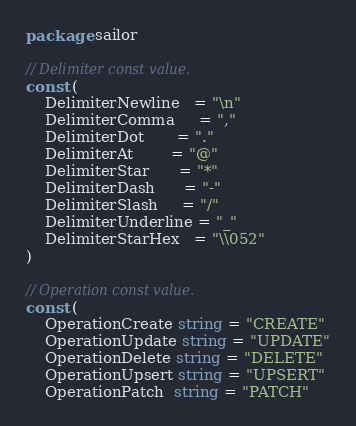<code> <loc_0><loc_0><loc_500><loc_500><_Go_>package sailor

// Delimiter const value.
const (
	DelimiterNewline   = "\n"
	DelimiterComma     = ","
	DelimiterDot       = "."
	DelimiterAt        = "@"
	DelimiterStar      = "*"
	DelimiterDash      = "-"
	DelimiterSlash     = "/"
	DelimiterUnderline = "_"
	DelimiterStarHex   = "\\052"
)

// Operation const value.
const (
	OperationCreate string = "CREATE"
	OperationUpdate string = "UPDATE"
	OperationDelete string = "DELETE"
	OperationUpsert string = "UPSERT"
	OperationPatch  string = "PATCH"</code> 